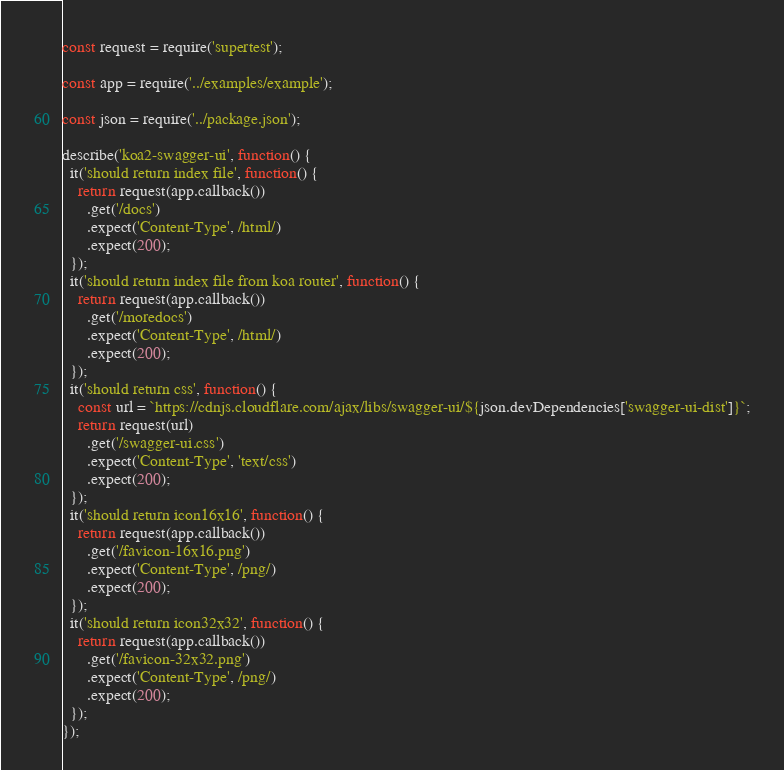<code> <loc_0><loc_0><loc_500><loc_500><_JavaScript_>const request = require('supertest');

const app = require('../examples/example');

const json = require('../package.json');

describe('koa2-swagger-ui', function() {
  it('should return index file', function() {
    return request(app.callback())
      .get('/docs')
      .expect('Content-Type', /html/)
      .expect(200);
  });
  it('should return index file from koa router', function() {
    return request(app.callback())
      .get('/moredocs')
      .expect('Content-Type', /html/)
      .expect(200);
  });
  it('should return css', function() {
    const url = `https://cdnjs.cloudflare.com/ajax/libs/swagger-ui/${json.devDependencies['swagger-ui-dist']}`;
    return request(url)
      .get('/swagger-ui.css')
      .expect('Content-Type', 'text/css')
      .expect(200);
  });
  it('should return icon16x16', function() {
    return request(app.callback())
      .get('/favicon-16x16.png')
      .expect('Content-Type', /png/)
      .expect(200);
  });
  it('should return icon32x32', function() {
    return request(app.callback())
      .get('/favicon-32x32.png')
      .expect('Content-Type', /png/)
      .expect(200);
  });
});
</code> 